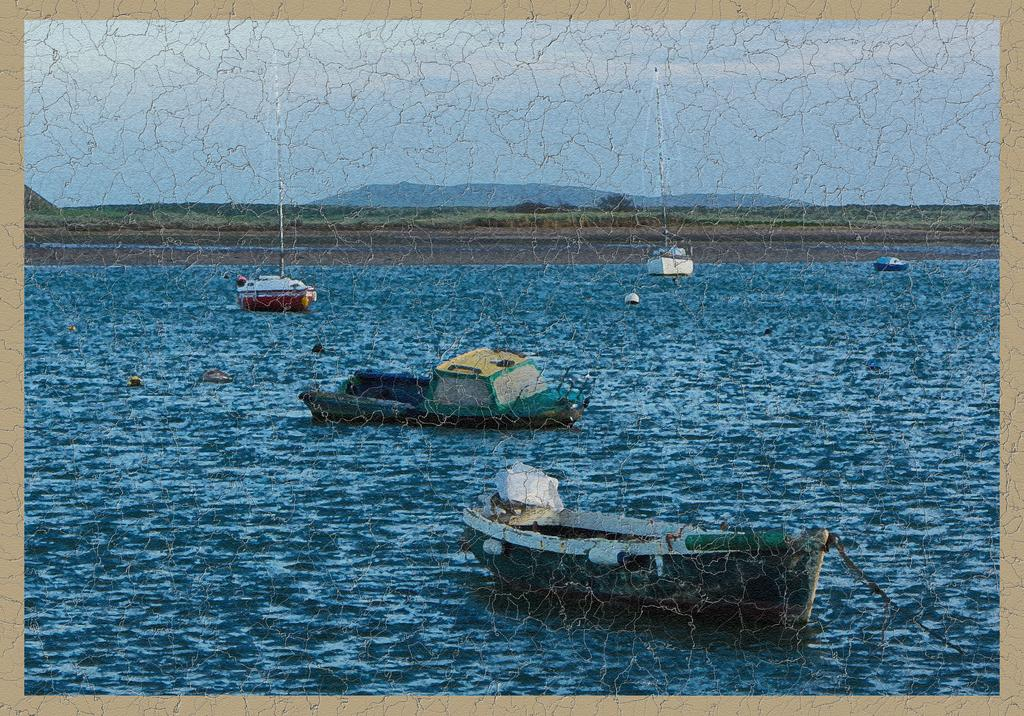What type of visual is the image? The image is a poster. What is depicted on the water in the image? There are boats on the water in the image. What type of vegetation can be seen in the background of the image? There is grass on the ground in the background. What natural features are visible in the background of the image? There are mountains and clouds visible in the background. What type of faucet is present in the image? There is no faucet present in the image. How long is the recess period in the image? There is no reference to a recess period in the image, as it features a poster with boats, grass, mountains, and clouds. 